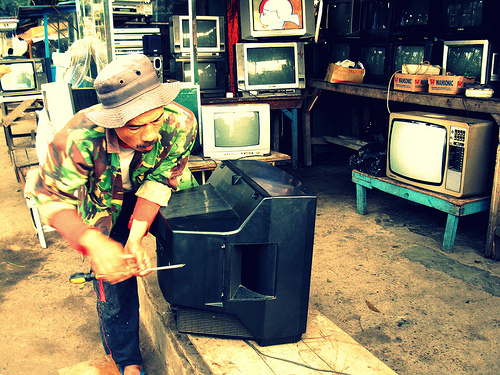<image>
Is the tv to the left of the man? No. The tv is not to the left of the man. From this viewpoint, they have a different horizontal relationship. 